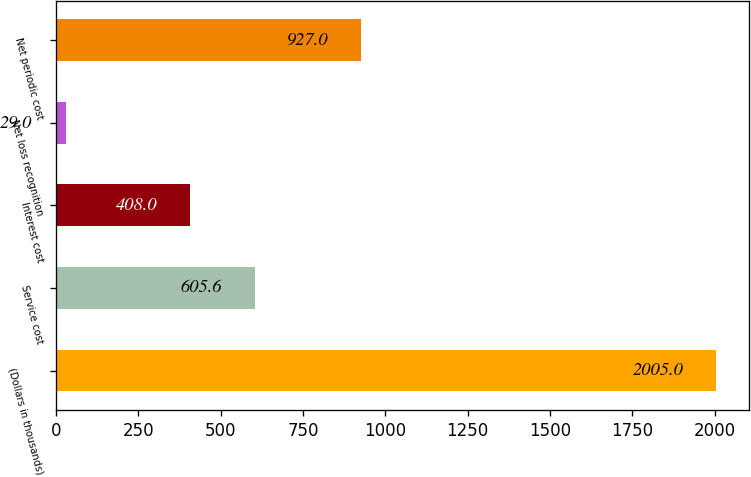<chart> <loc_0><loc_0><loc_500><loc_500><bar_chart><fcel>(Dollars in thousands)<fcel>Service cost<fcel>Interest cost<fcel>Net loss recognition<fcel>Net periodic cost<nl><fcel>2005<fcel>605.6<fcel>408<fcel>29<fcel>927<nl></chart> 